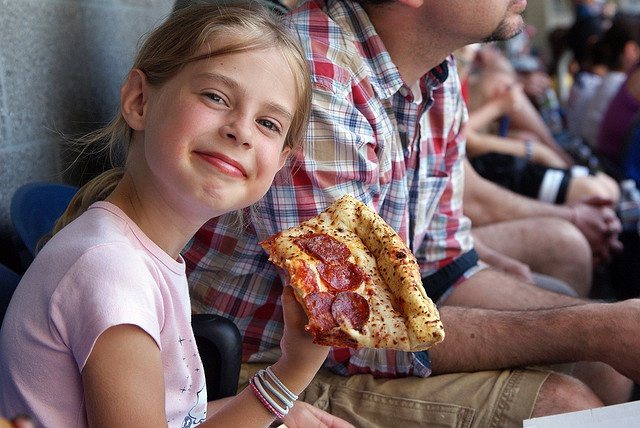Describe the objects in this image and their specific colors. I can see people in darkgray, gray, maroon, and black tones, people in darkgray, brown, gray, lavender, and tan tones, pizza in darkgray, maroon, brown, and tan tones, people in darkgray, black, lightgray, and gray tones, and people in darkgray and gray tones in this image. 